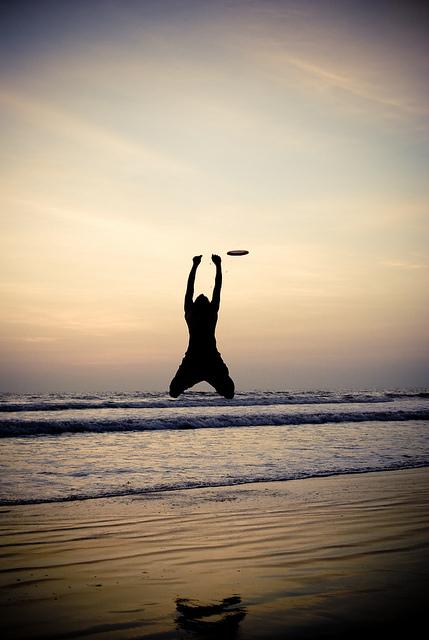Why are his arms in the air?
Write a very short answer. Catching frisbee. Is this a victory jump?
Answer briefly. Yes. Can you see the face of the person in the image?
Answer briefly. No. 